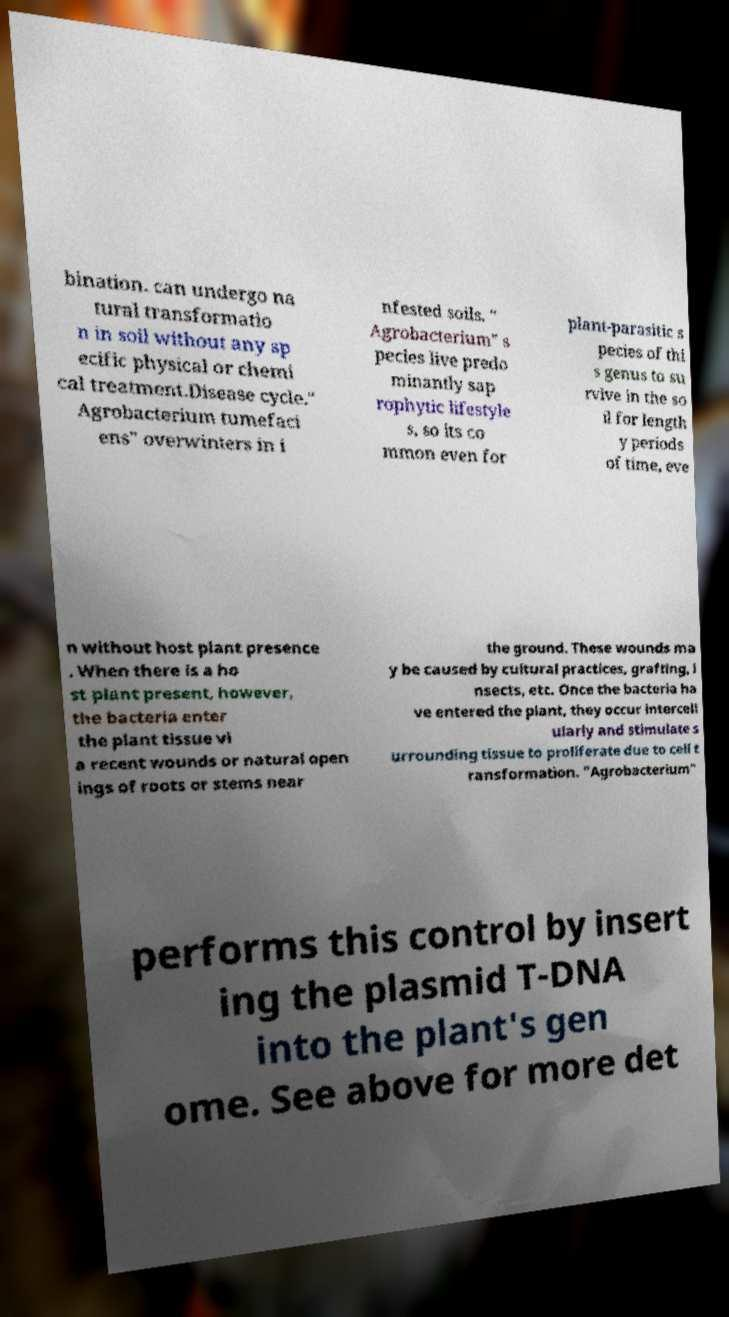Can you read and provide the text displayed in the image?This photo seems to have some interesting text. Can you extract and type it out for me? bination. can undergo na tural transformatio n in soil without any sp ecific physical or chemi cal treatment.Disease cycle." Agrobacterium tumefaci ens" overwinters in i nfested soils. " Agrobacterium" s pecies live predo minantly sap rophytic lifestyle s, so its co mmon even for plant-parasitic s pecies of thi s genus to su rvive in the so il for length y periods of time, eve n without host plant presence . When there is a ho st plant present, however, the bacteria enter the plant tissue vi a recent wounds or natural open ings of roots or stems near the ground. These wounds ma y be caused by cultural practices, grafting, i nsects, etc. Once the bacteria ha ve entered the plant, they occur intercell ularly and stimulate s urrounding tissue to proliferate due to cell t ransformation. "Agrobacterium" performs this control by insert ing the plasmid T-DNA into the plant's gen ome. See above for more det 